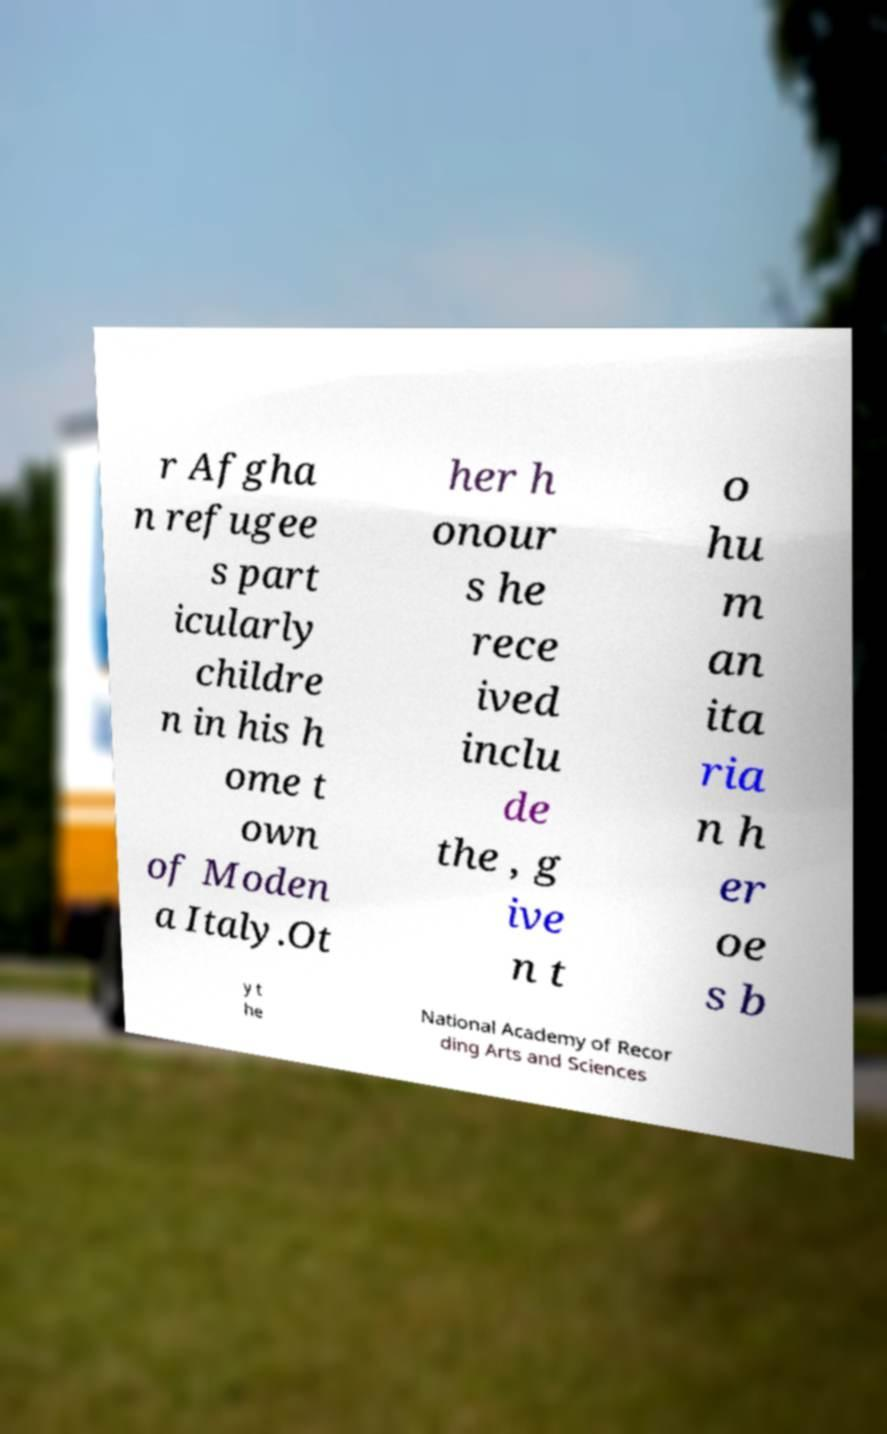Please read and relay the text visible in this image. What does it say? r Afgha n refugee s part icularly childre n in his h ome t own of Moden a Italy.Ot her h onour s he rece ived inclu de the , g ive n t o hu m an ita ria n h er oe s b y t he National Academy of Recor ding Arts and Sciences 